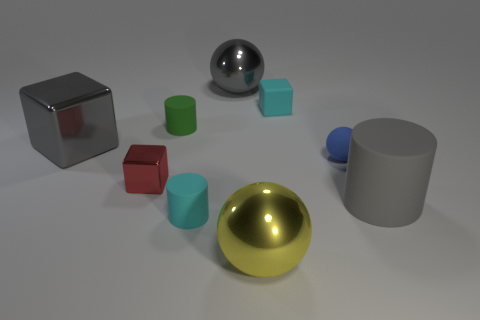Subtract all tiny matte cylinders. How many cylinders are left? 1 Subtract all cyan blocks. How many blocks are left? 2 Subtract all cubes. How many objects are left? 6 Subtract 1 cylinders. How many cylinders are left? 2 Subtract all large metallic blocks. Subtract all blue matte objects. How many objects are left? 7 Add 1 big yellow balls. How many big yellow balls are left? 2 Add 7 big gray blocks. How many big gray blocks exist? 8 Subtract 0 brown spheres. How many objects are left? 9 Subtract all red cylinders. Subtract all brown blocks. How many cylinders are left? 3 Subtract all gray cylinders. How many brown cubes are left? 0 